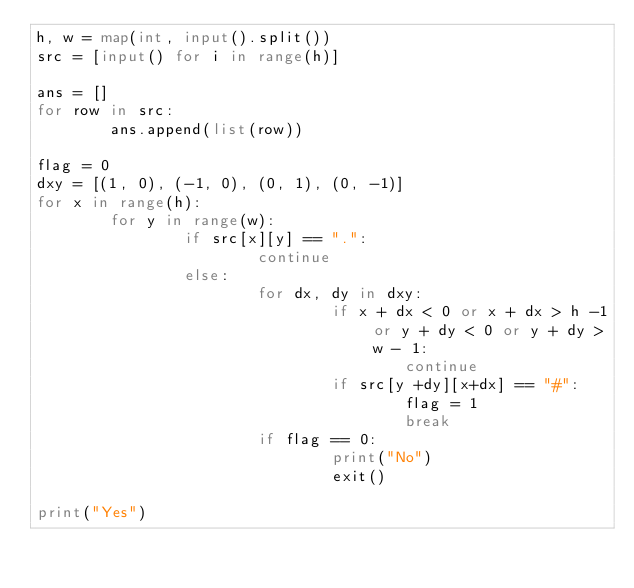Convert code to text. <code><loc_0><loc_0><loc_500><loc_500><_Python_>h, w = map(int, input().split())
src = [input() for i in range(h)]

ans = []
for row in src:
        ans.append(list(row))

flag = 0
dxy = [(1, 0), (-1, 0), (0, 1), (0, -1)]
for x in range(h):
        for y in range(w):
                if src[x][y] == ".":
                        continue
                else:
                        for dx, dy in dxy:
                                if x + dx < 0 or x + dx > h -1 or y + dy < 0 or y + dy > w - 1:
                                        continue
                                if src[y +dy][x+dx] == "#":
                                        flag = 1
                                        break
                        if flag == 0:
                                print("No")
                                exit()

print("Yes")</code> 